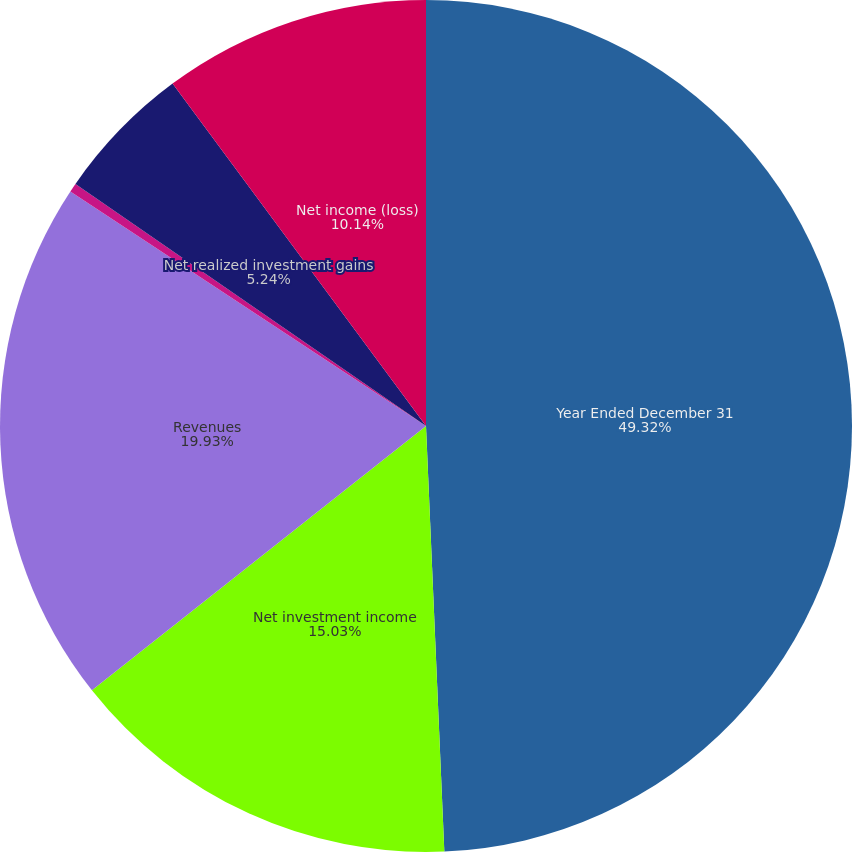Convert chart to OTSL. <chart><loc_0><loc_0><loc_500><loc_500><pie_chart><fcel>Year Ended December 31<fcel>Net investment income<fcel>Revenues<fcel>Net operating income (loss)<fcel>Net realized investment gains<fcel>Net income (loss)<nl><fcel>49.31%<fcel>15.03%<fcel>19.93%<fcel>0.34%<fcel>5.24%<fcel>10.14%<nl></chart> 